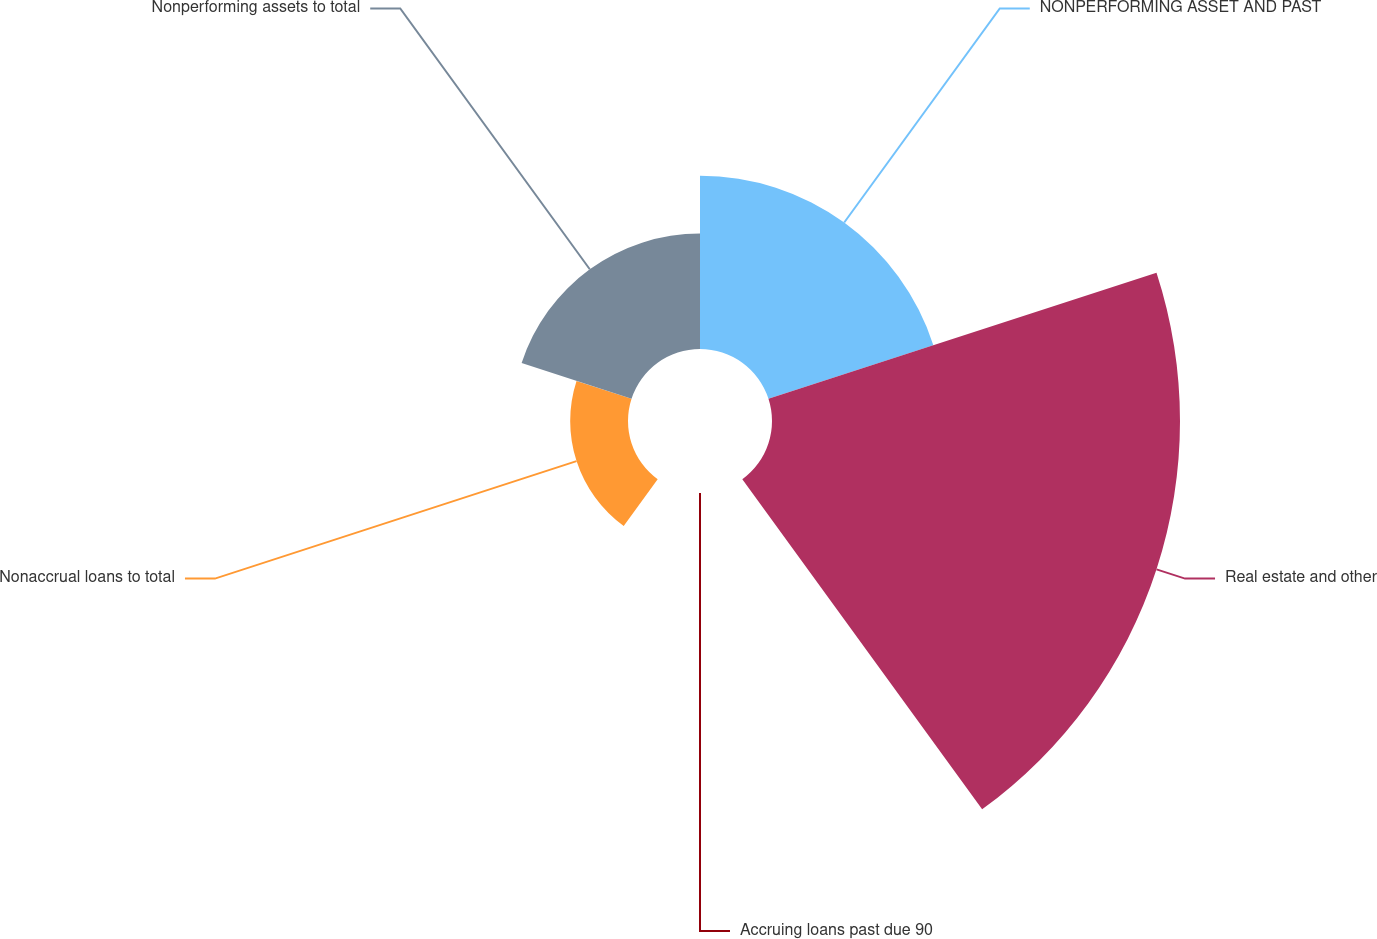Convert chart. <chart><loc_0><loc_0><loc_500><loc_500><pie_chart><fcel>NONPERFORMING ASSET AND PAST<fcel>Real estate and other<fcel>Accruing loans past due 90<fcel>Nonaccrual loans to total<fcel>Nonperforming assets to total<nl><fcel>22.97%<fcel>54.06%<fcel>0.0%<fcel>7.66%<fcel>15.31%<nl></chart> 